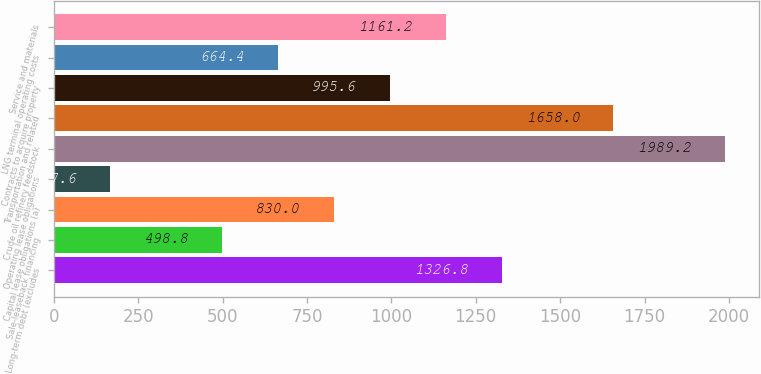<chart> <loc_0><loc_0><loc_500><loc_500><bar_chart><fcel>Long-term debt (excludes<fcel>Sale-leaseback financing<fcel>Capital lease obligations (a)<fcel>Operating lease obligations<fcel>Crude oil refinery feedstock<fcel>Transportation and related<fcel>Contracts to acquire property<fcel>LNG terminal operating costs<fcel>Service and materials<nl><fcel>1326.8<fcel>498.8<fcel>830<fcel>167.6<fcel>1989.2<fcel>1658<fcel>995.6<fcel>664.4<fcel>1161.2<nl></chart> 